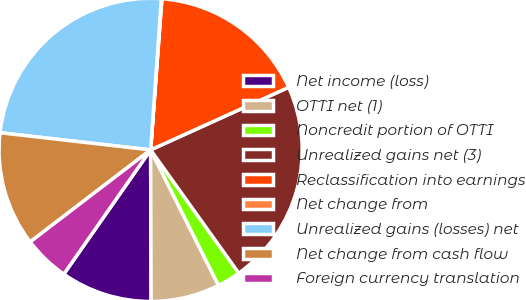<chart> <loc_0><loc_0><loc_500><loc_500><pie_chart><fcel>Net income (loss)<fcel>OTTI net (1)<fcel>Noncredit portion of OTTI<fcel>Unrealized gains net (3)<fcel>Reclassification into earnings<fcel>Net change from<fcel>Unrealized gains (losses) net<fcel>Net change from cash flow<fcel>Foreign currency translation<nl><fcel>9.76%<fcel>7.34%<fcel>2.49%<fcel>21.89%<fcel>17.04%<fcel>0.06%<fcel>24.32%<fcel>12.19%<fcel>4.91%<nl></chart> 